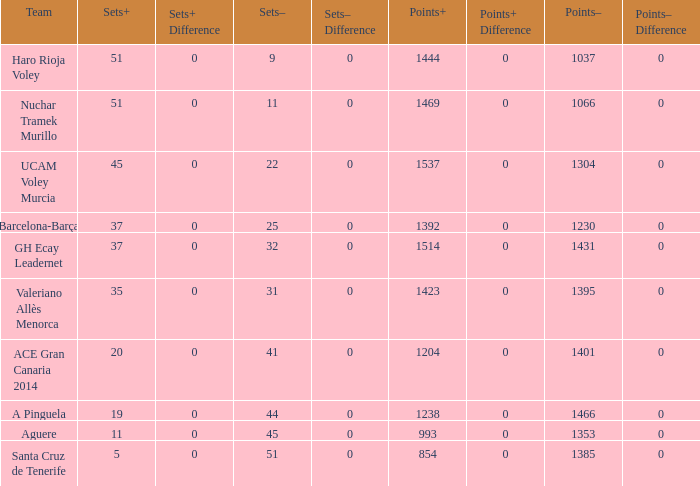Who is the team who had a Sets+ number smaller than 20, a Sets- number of 45, and a Points+ number smaller than 1238? Aguere. Could you help me parse every detail presented in this table? {'header': ['Team', 'Sets+', 'Sets+ Difference', 'Sets–', 'Sets– Difference', 'Points+', 'Points+ Difference', 'Points–', 'Points– Difference'], 'rows': [['Haro Rioja Voley', '51', '0', '9', '0', '1444', '0', '1037', '0'], ['Nuchar Tramek Murillo', '51', '0', '11', '0', '1469', '0', '1066', '0'], ['UCAM Voley Murcia', '45', '0', '22', '0', '1537', '0', '1304', '0'], ['Barcelona-Barça', '37', '0', '25', '0', '1392', '0', '1230', '0'], ['GH Ecay Leadernet', '37', '0', '32', '0', '1514', '0', '1431', '0'], ['Valeriano Allès Menorca', '35', '0', '31', '0', '1423', '0', '1395', '0'], ['ACE Gran Canaria 2014', '20', '0', '41', '0', '1204', '0', '1401', '0'], ['A Pinguela', '19', '0', '44', '0', '1238', '0', '1466', '0'], ['Aguere', '11', '0', '45', '0', '993', '0', '1353', '0'], ['Santa Cruz de Tenerife', '5', '0', '51', '0', '854', '0', '1385', '0']]} 